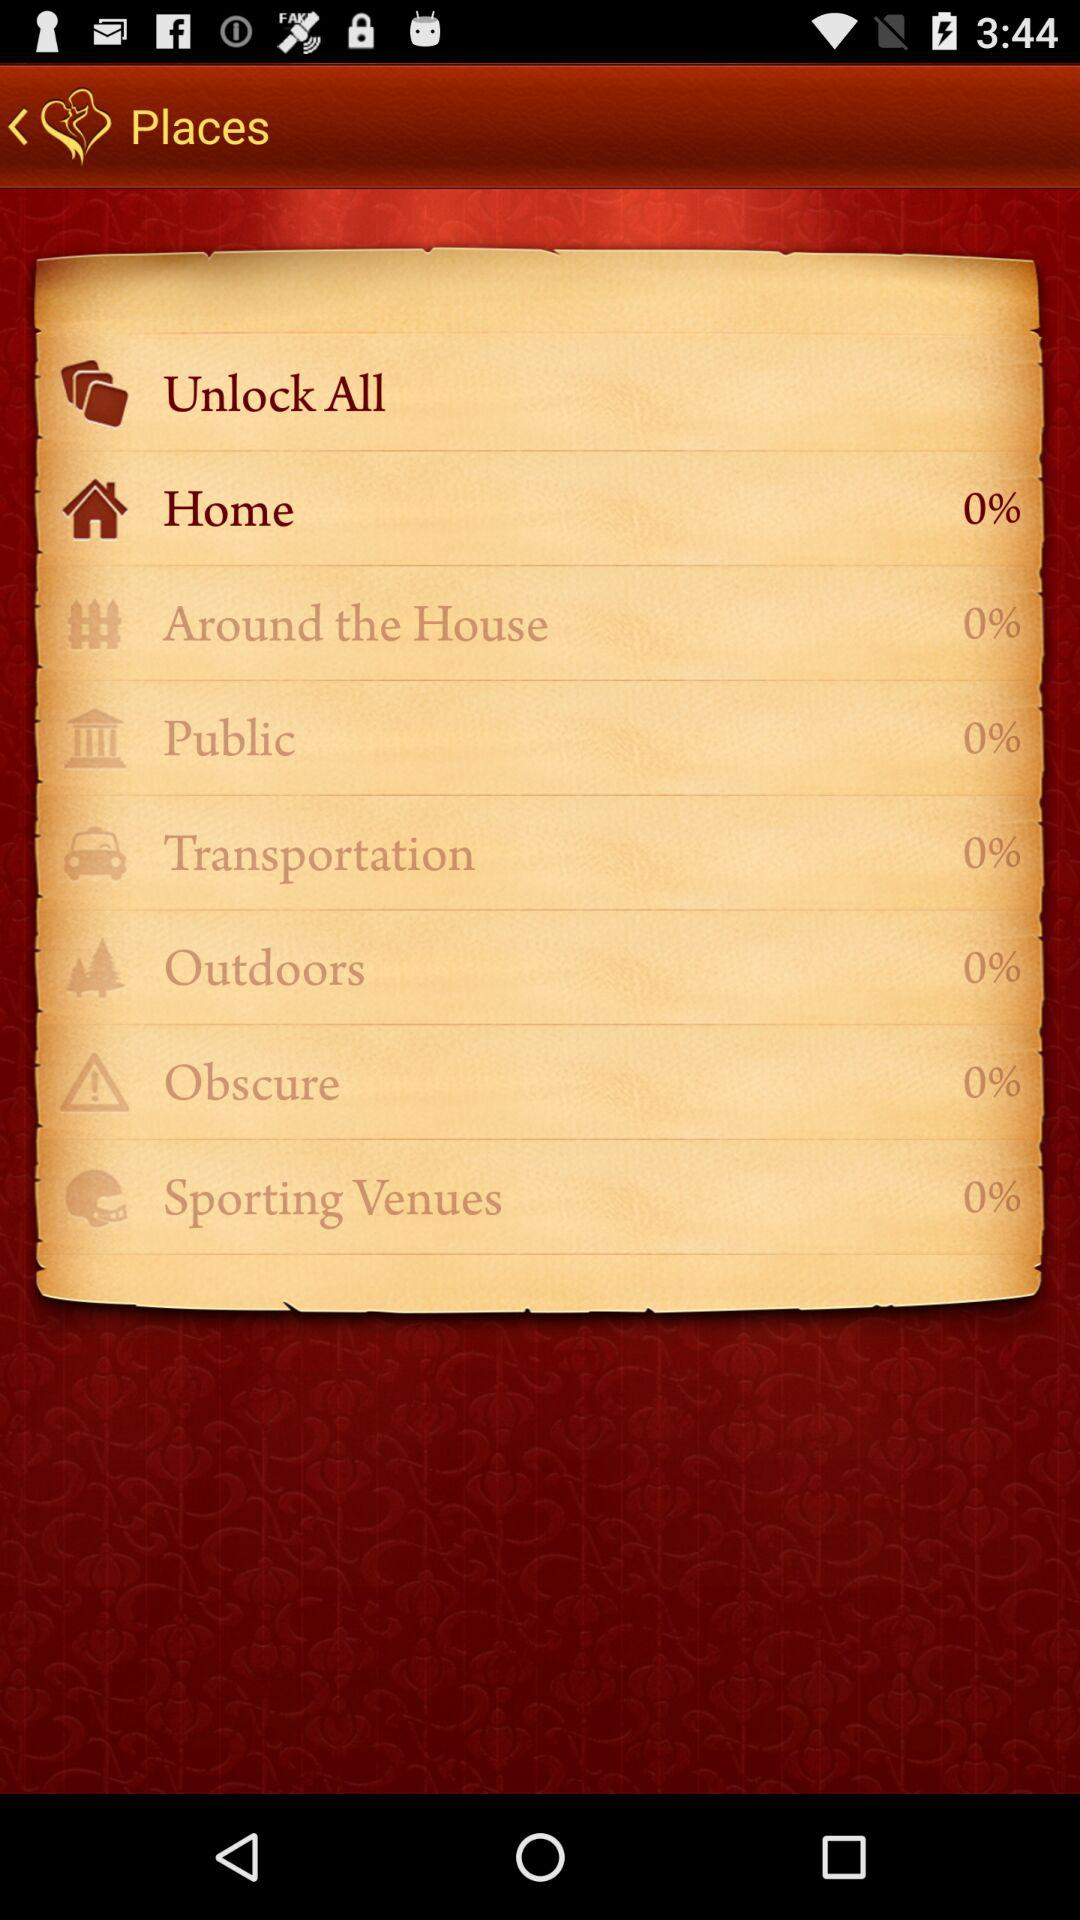Who is the user?
When the provided information is insufficient, respond with <no answer>. <no answer> 